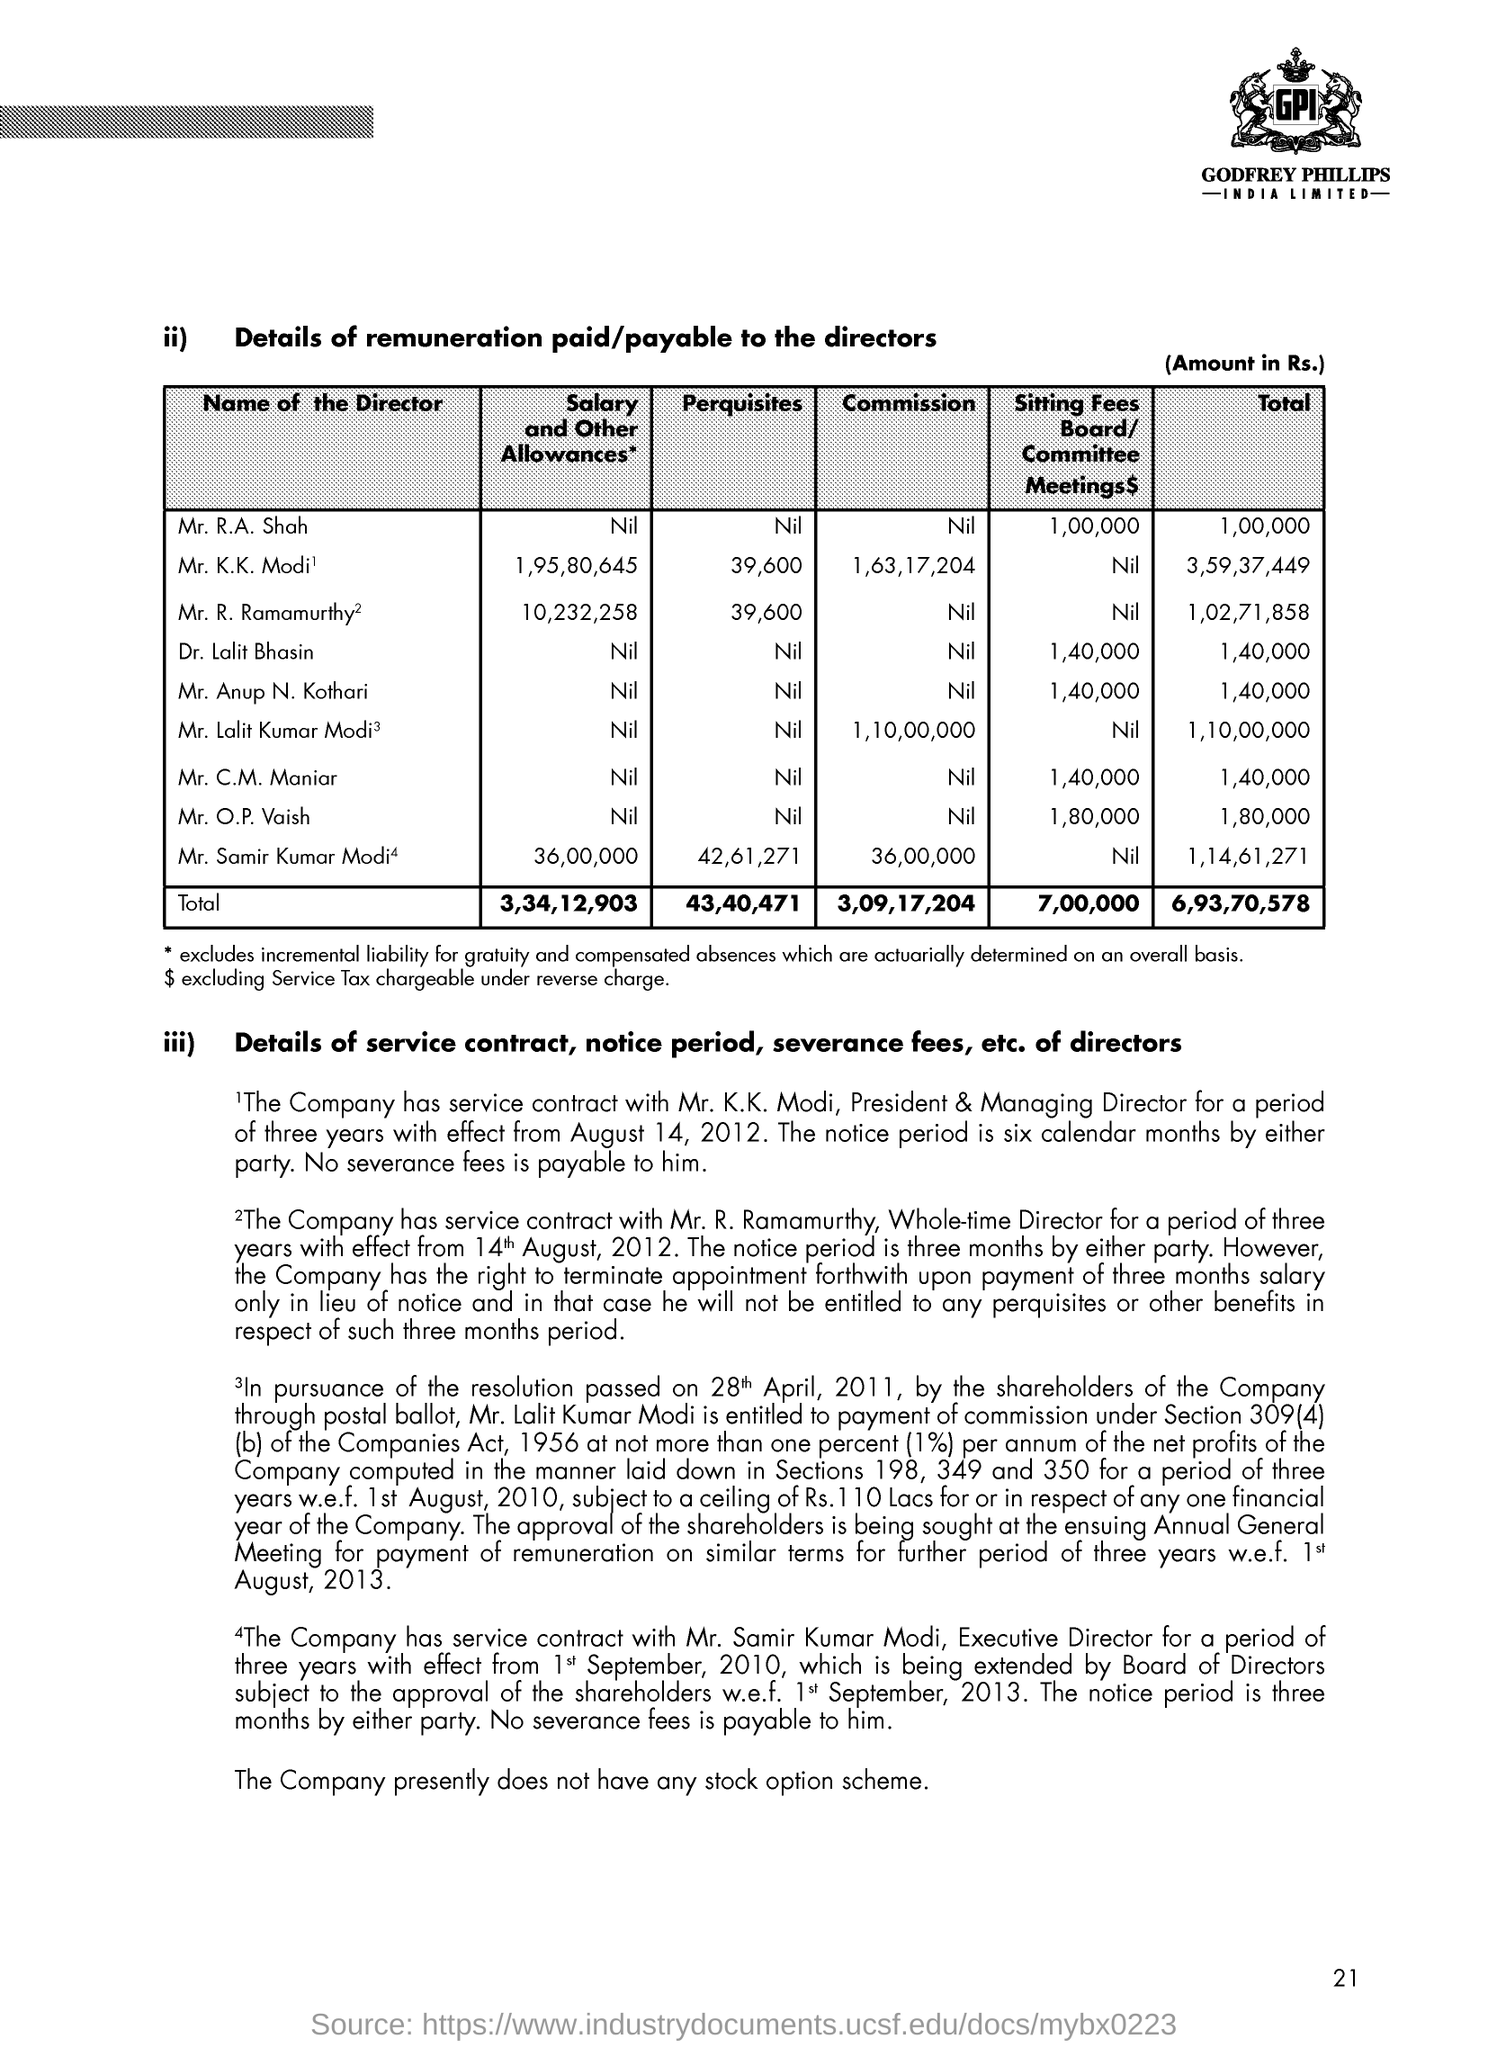Who is the president & managing director  of the company for a period of three years  ?
Give a very brief answer. Mr. k.K. Modi. What is the total  remuneration paid to mr . r. a shah ?
Provide a short and direct response. 1,00,000. What is the total remuneration paid to all the directors ?
Provide a short and direct response. 6,93,70,578. What is the salary and other allowances to mr samir kumar modi
Your answer should be compact. 36,00,000. What is the total remuneration paid to mr . k.k modi ?
Your response must be concise. 3,59,37,449. What is the total of perquisites for all the directors ?
Provide a succinct answer. 43,40,471. What is the commission for mr. k.k. modi
Provide a short and direct response. 1,63,17,204. What is the total commission  for all the directors ?
Your response must be concise. 3,09,17,204. 